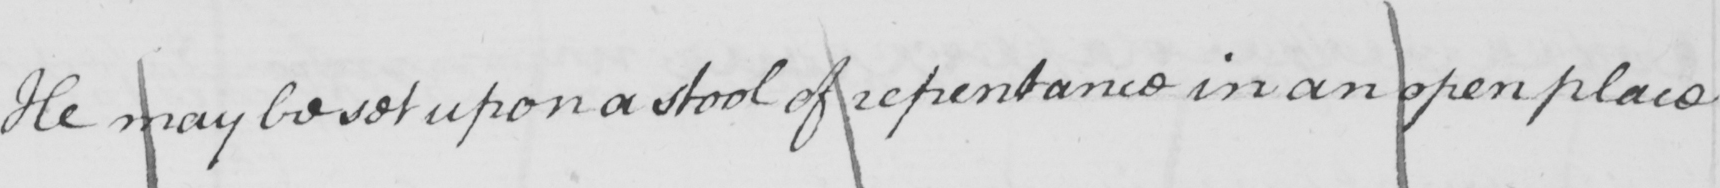What text is written in this handwritten line? He may be set upon a stool of repentance in an open place 